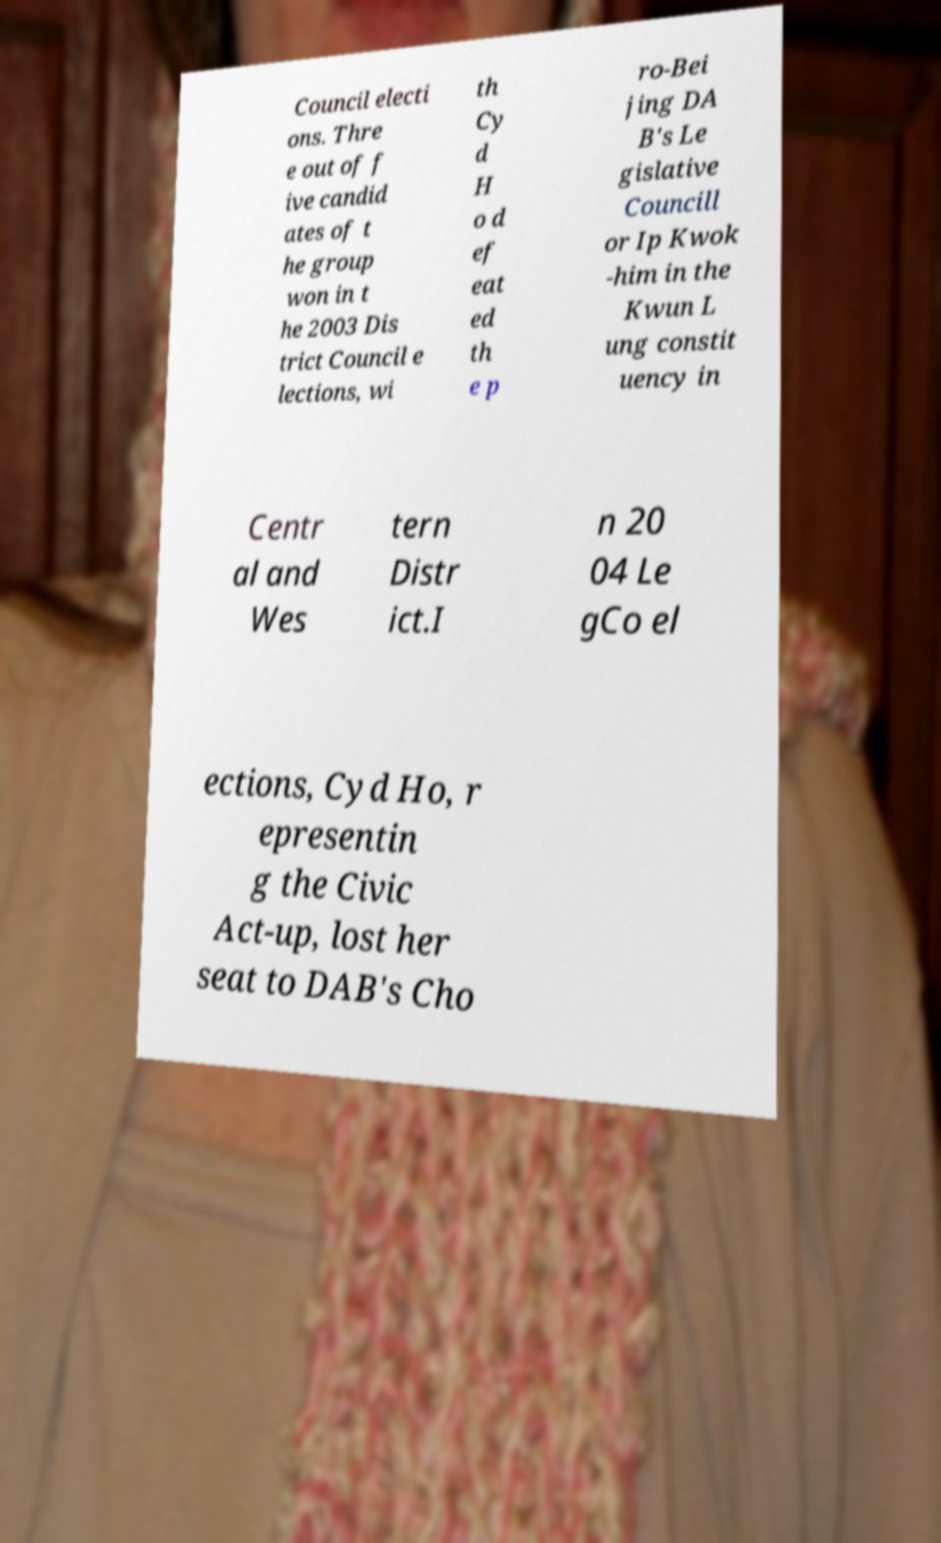Please read and relay the text visible in this image. What does it say? Council electi ons. Thre e out of f ive candid ates of t he group won in t he 2003 Dis trict Council e lections, wi th Cy d H o d ef eat ed th e p ro-Bei jing DA B's Le gislative Councill or Ip Kwok -him in the Kwun L ung constit uency in Centr al and Wes tern Distr ict.I n 20 04 Le gCo el ections, Cyd Ho, r epresentin g the Civic Act-up, lost her seat to DAB's Cho 